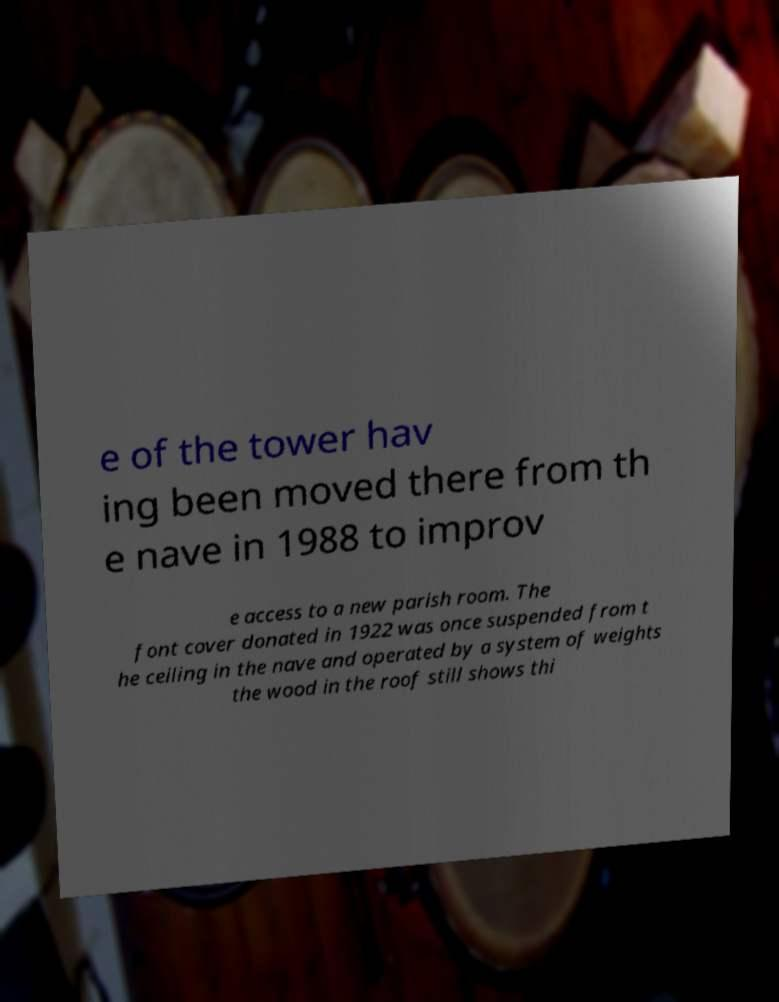Please read and relay the text visible in this image. What does it say? e of the tower hav ing been moved there from th e nave in 1988 to improv e access to a new parish room. The font cover donated in 1922 was once suspended from t he ceiling in the nave and operated by a system of weights the wood in the roof still shows thi 